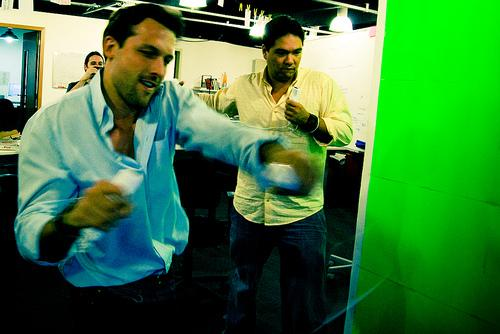What activity is the individual engaging in?

Choices:
A) running
B) boxing
C) taekwondo
D) climbing boxing 